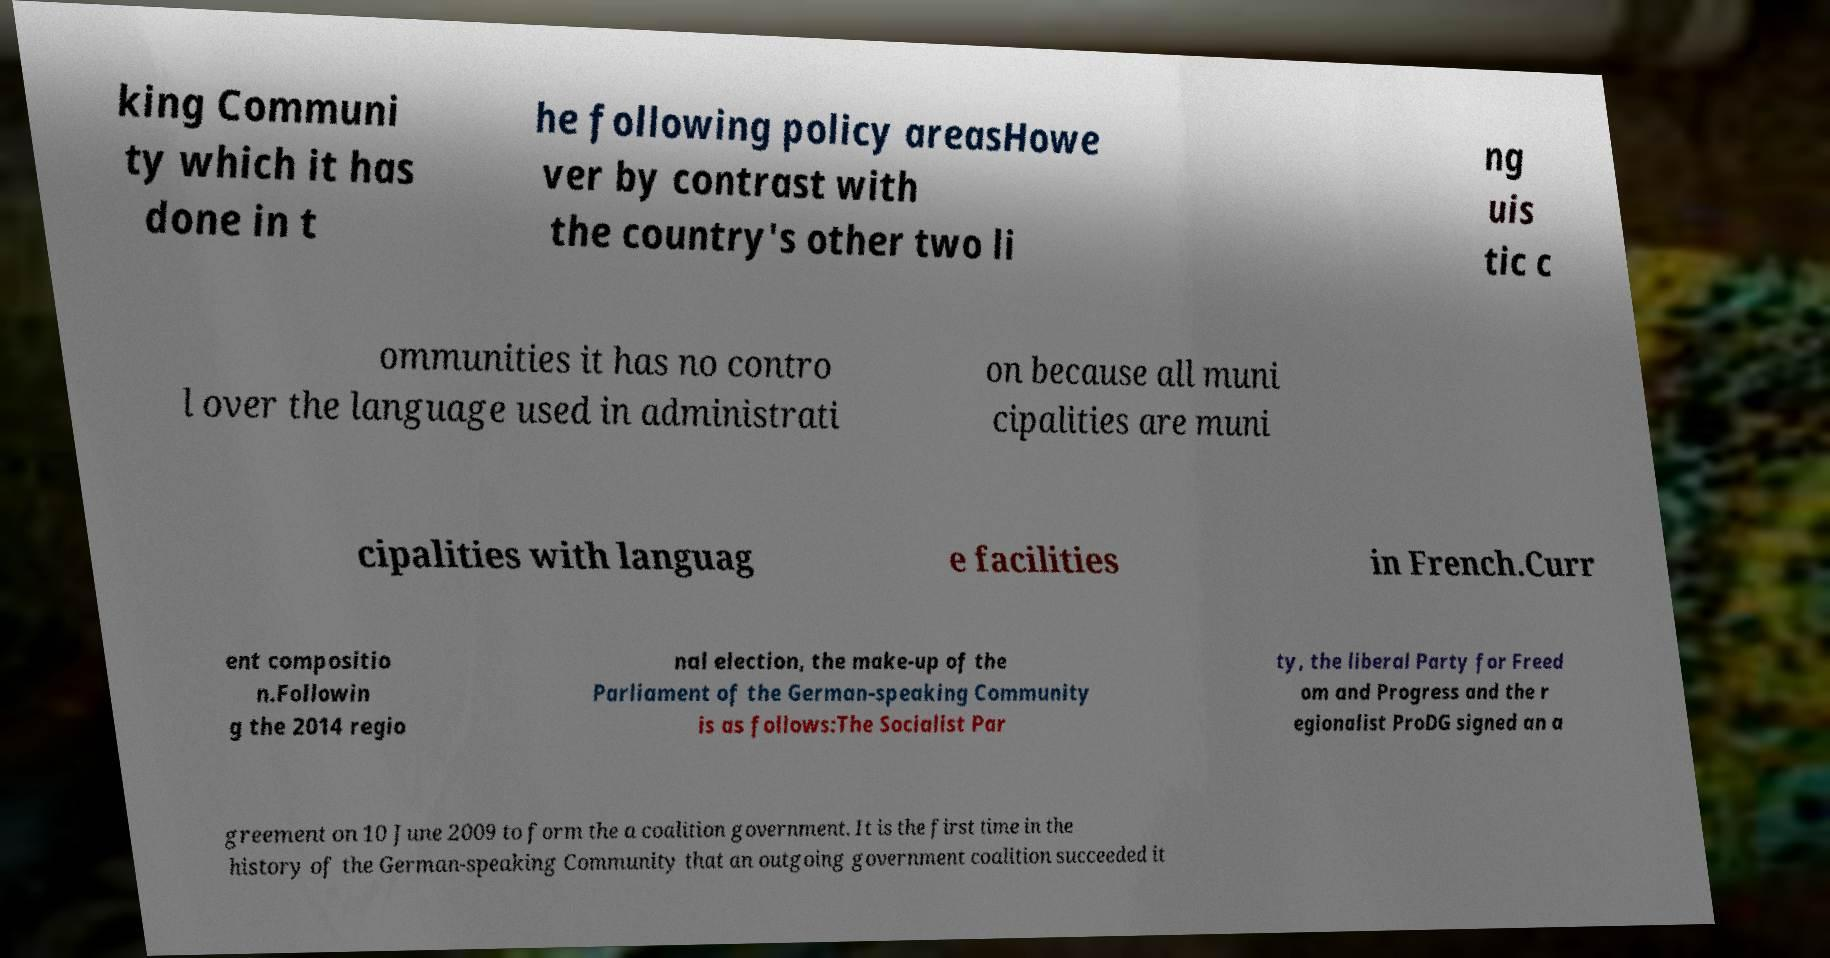What messages or text are displayed in this image? I need them in a readable, typed format. king Communi ty which it has done in t he following policy areasHowe ver by contrast with the country's other two li ng uis tic c ommunities it has no contro l over the language used in administrati on because all muni cipalities are muni cipalities with languag e facilities in French.Curr ent compositio n.Followin g the 2014 regio nal election, the make-up of the Parliament of the German-speaking Community is as follows:The Socialist Par ty, the liberal Party for Freed om and Progress and the r egionalist ProDG signed an a greement on 10 June 2009 to form the a coalition government. It is the first time in the history of the German-speaking Community that an outgoing government coalition succeeded it 